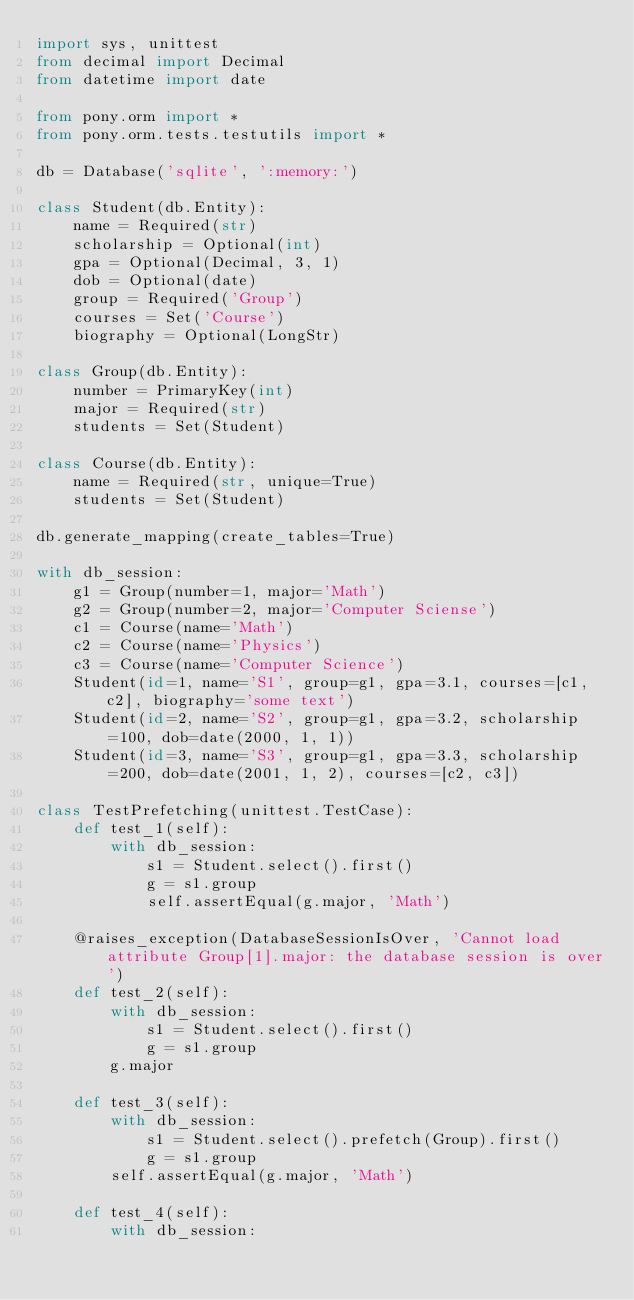Convert code to text. <code><loc_0><loc_0><loc_500><loc_500><_Python_>import sys, unittest
from decimal import Decimal
from datetime import date

from pony.orm import *
from pony.orm.tests.testutils import *

db = Database('sqlite', ':memory:')

class Student(db.Entity):
    name = Required(str)
    scholarship = Optional(int)
    gpa = Optional(Decimal, 3, 1)
    dob = Optional(date)
    group = Required('Group')
    courses = Set('Course')
    biography = Optional(LongStr)

class Group(db.Entity):
    number = PrimaryKey(int)
    major = Required(str)
    students = Set(Student)

class Course(db.Entity):
    name = Required(str, unique=True)
    students = Set(Student)

db.generate_mapping(create_tables=True)

with db_session:
    g1 = Group(number=1, major='Math')
    g2 = Group(number=2, major='Computer Sciense')
    c1 = Course(name='Math')
    c2 = Course(name='Physics')
    c3 = Course(name='Computer Science')
    Student(id=1, name='S1', group=g1, gpa=3.1, courses=[c1, c2], biography='some text')
    Student(id=2, name='S2', group=g1, gpa=3.2, scholarship=100, dob=date(2000, 1, 1))
    Student(id=3, name='S3', group=g1, gpa=3.3, scholarship=200, dob=date(2001, 1, 2), courses=[c2, c3])

class TestPrefetching(unittest.TestCase):
    def test_1(self):
        with db_session:
            s1 = Student.select().first()
            g = s1.group
            self.assertEqual(g.major, 'Math')

    @raises_exception(DatabaseSessionIsOver, 'Cannot load attribute Group[1].major: the database session is over')
    def test_2(self):
        with db_session:
            s1 = Student.select().first()
            g = s1.group
        g.major

    def test_3(self):
        with db_session:
            s1 = Student.select().prefetch(Group).first()
            g = s1.group
        self.assertEqual(g.major, 'Math')

    def test_4(self):
        with db_session:</code> 